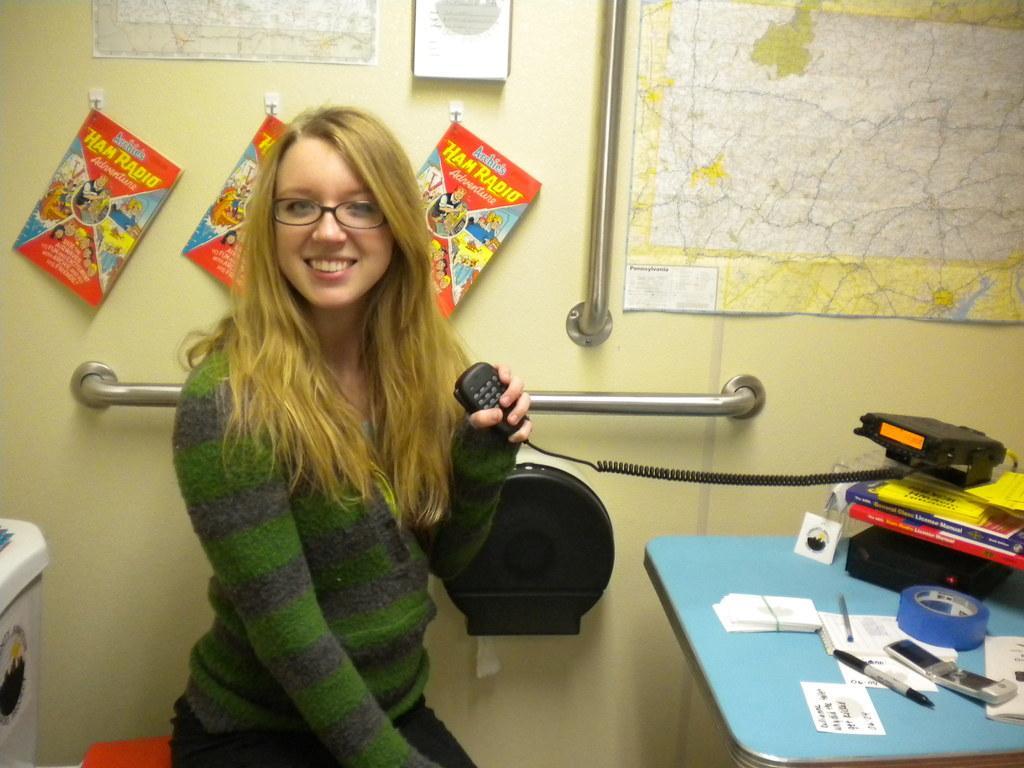Can you describe this image briefly? In this image on the left side there is one woman who is sitting and smiling and she is holding a mike and on the right side there is one table on the table there are some papers, pens, mobile, books and one tape is there. On the top there is a wall on the wall there are some books and one poster is there. 